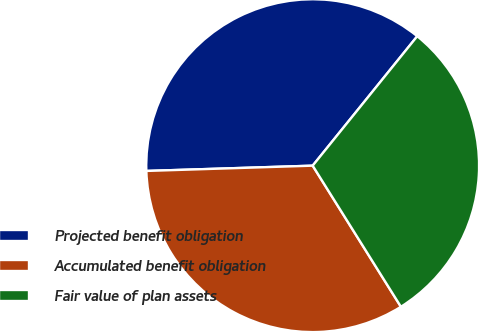Convert chart to OTSL. <chart><loc_0><loc_0><loc_500><loc_500><pie_chart><fcel>Projected benefit obligation<fcel>Accumulated benefit obligation<fcel>Fair value of plan assets<nl><fcel>36.32%<fcel>33.39%<fcel>30.29%<nl></chart> 